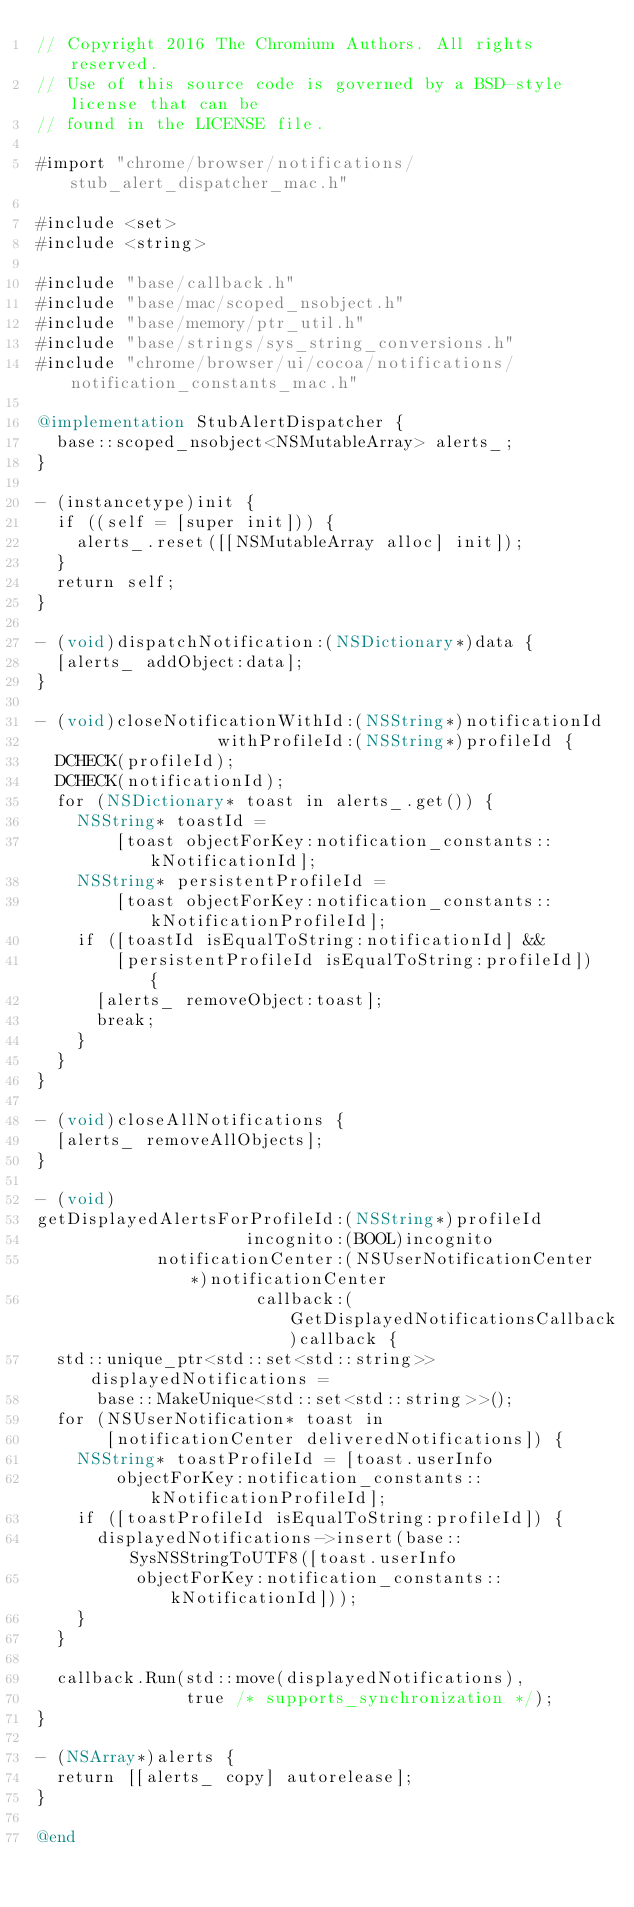<code> <loc_0><loc_0><loc_500><loc_500><_ObjectiveC_>// Copyright 2016 The Chromium Authors. All rights reserved.
// Use of this source code is governed by a BSD-style license that can be
// found in the LICENSE file.

#import "chrome/browser/notifications/stub_alert_dispatcher_mac.h"

#include <set>
#include <string>

#include "base/callback.h"
#include "base/mac/scoped_nsobject.h"
#include "base/memory/ptr_util.h"
#include "base/strings/sys_string_conversions.h"
#include "chrome/browser/ui/cocoa/notifications/notification_constants_mac.h"

@implementation StubAlertDispatcher {
  base::scoped_nsobject<NSMutableArray> alerts_;
}

- (instancetype)init {
  if ((self = [super init])) {
    alerts_.reset([[NSMutableArray alloc] init]);
  }
  return self;
}

- (void)dispatchNotification:(NSDictionary*)data {
  [alerts_ addObject:data];
}

- (void)closeNotificationWithId:(NSString*)notificationId
                  withProfileId:(NSString*)profileId {
  DCHECK(profileId);
  DCHECK(notificationId);
  for (NSDictionary* toast in alerts_.get()) {
    NSString* toastId =
        [toast objectForKey:notification_constants::kNotificationId];
    NSString* persistentProfileId =
        [toast objectForKey:notification_constants::kNotificationProfileId];
    if ([toastId isEqualToString:notificationId] &&
        [persistentProfileId isEqualToString:profileId]) {
      [alerts_ removeObject:toast];
      break;
    }
  }
}

- (void)closeAllNotifications {
  [alerts_ removeAllObjects];
}

- (void)
getDisplayedAlertsForProfileId:(NSString*)profileId
                     incognito:(BOOL)incognito
            notificationCenter:(NSUserNotificationCenter*)notificationCenter
                      callback:(GetDisplayedNotificationsCallback)callback {
  std::unique_ptr<std::set<std::string>> displayedNotifications =
      base::MakeUnique<std::set<std::string>>();
  for (NSUserNotification* toast in
       [notificationCenter deliveredNotifications]) {
    NSString* toastProfileId = [toast.userInfo
        objectForKey:notification_constants::kNotificationProfileId];
    if ([toastProfileId isEqualToString:profileId]) {
      displayedNotifications->insert(base::SysNSStringToUTF8([toast.userInfo
          objectForKey:notification_constants::kNotificationId]));
    }
  }

  callback.Run(std::move(displayedNotifications),
               true /* supports_synchronization */);
}

- (NSArray*)alerts {
  return [[alerts_ copy] autorelease];
}

@end
</code> 